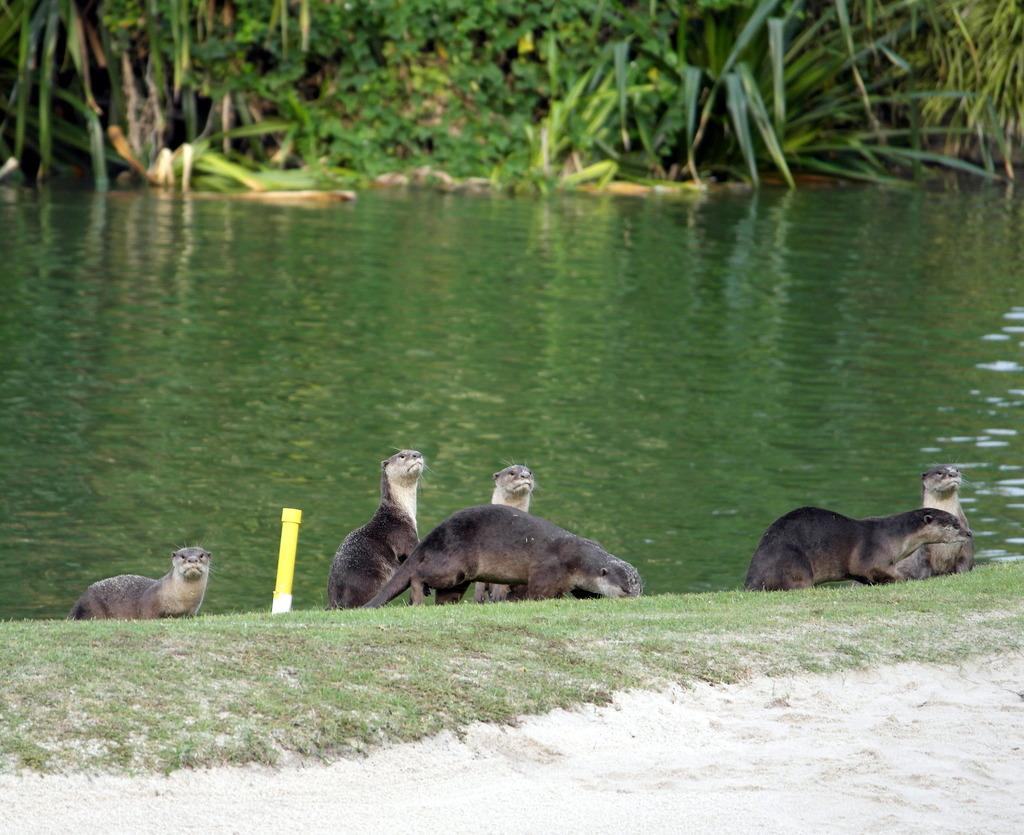What is the main subject in the foreground of the image? There is a cat in the foreground of the image. What is the cat doing in the image? The cat is yawning on the grass. What can be seen in the background of the image? There is water, plants, and trees visible in the background of the image. What type of advertisement can be seen on the cat's collar in the image? There is no advertisement or collar visible on the cat in the image. 